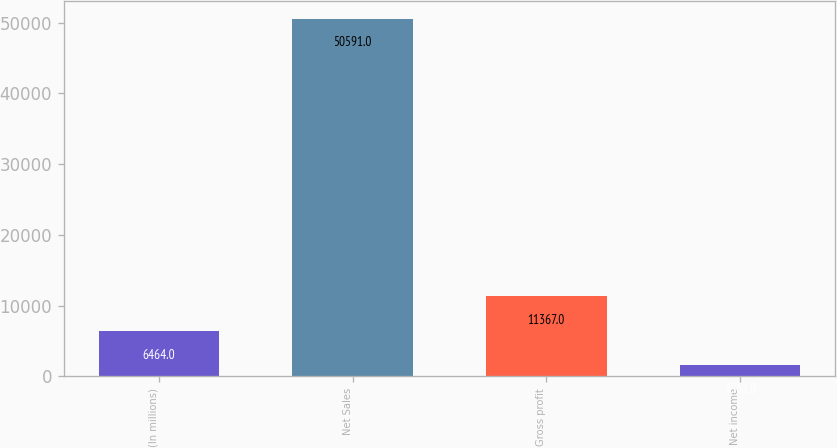Convert chart. <chart><loc_0><loc_0><loc_500><loc_500><bar_chart><fcel>(In millions)<fcel>Net Sales<fcel>Gross profit<fcel>Net income<nl><fcel>6464<fcel>50591<fcel>11367<fcel>1561<nl></chart> 